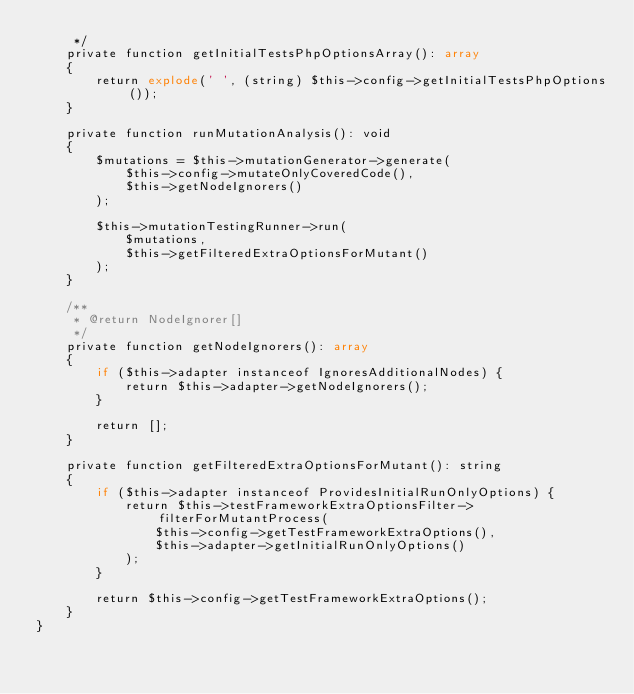<code> <loc_0><loc_0><loc_500><loc_500><_PHP_>     */
    private function getInitialTestsPhpOptionsArray(): array
    {
        return explode(' ', (string) $this->config->getInitialTestsPhpOptions());
    }

    private function runMutationAnalysis(): void
    {
        $mutations = $this->mutationGenerator->generate(
            $this->config->mutateOnlyCoveredCode(),
            $this->getNodeIgnorers()
        );

        $this->mutationTestingRunner->run(
            $mutations,
            $this->getFilteredExtraOptionsForMutant()
        );
    }

    /**
     * @return NodeIgnorer[]
     */
    private function getNodeIgnorers(): array
    {
        if ($this->adapter instanceof IgnoresAdditionalNodes) {
            return $this->adapter->getNodeIgnorers();
        }

        return [];
    }

    private function getFilteredExtraOptionsForMutant(): string
    {
        if ($this->adapter instanceof ProvidesInitialRunOnlyOptions) {
            return $this->testFrameworkExtraOptionsFilter->filterForMutantProcess(
                $this->config->getTestFrameworkExtraOptions(),
                $this->adapter->getInitialRunOnlyOptions()
            );
        }

        return $this->config->getTestFrameworkExtraOptions();
    }
}
</code> 